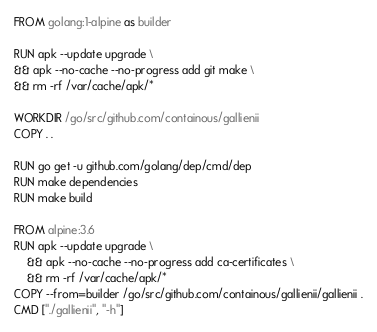Convert code to text. <code><loc_0><loc_0><loc_500><loc_500><_Dockerfile_>FROM golang:1-alpine as builder

RUN apk --update upgrade \
&& apk --no-cache --no-progress add git make \
&& rm -rf /var/cache/apk/*

WORKDIR /go/src/github.com/containous/gallienii
COPY . .

RUN go get -u github.com/golang/dep/cmd/dep
RUN make dependencies
RUN make build

FROM alpine:3.6
RUN apk --update upgrade \
    && apk --no-cache --no-progress add ca-certificates \
    && rm -rf /var/cache/apk/*
COPY --from=builder /go/src/github.com/containous/gallienii/gallienii .
CMD ["./gallienii", "-h"]</code> 